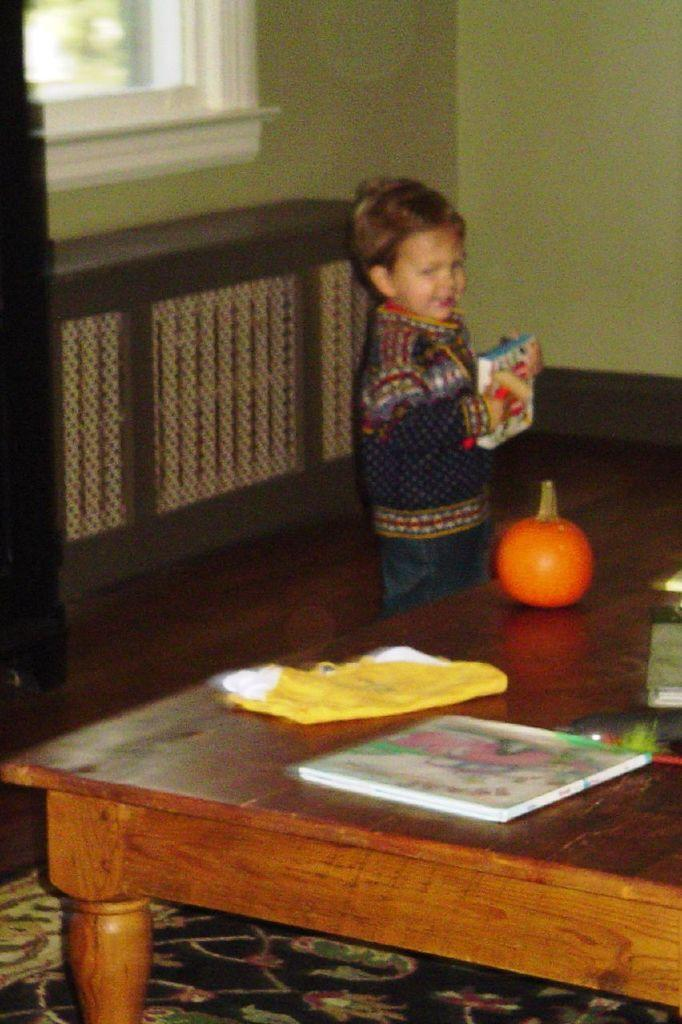What is the person in the image holding? The person is holding a book in the center of the image. What is the primary piece of furniture in the image? There is a table in the image. What can be found on the table? There are objects on the table. What can be seen in the background of the image? There is a wall and a window in the background of the image. What type of religion is being practiced in the image? There is no indication of any religious practice in the image. How many feet can be seen in the image? There is no visible foot or feet in the image. 